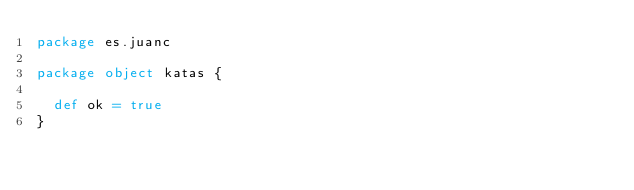Convert code to text. <code><loc_0><loc_0><loc_500><loc_500><_Scala_>package es.juanc

package object katas {

  def ok = true
}
</code> 